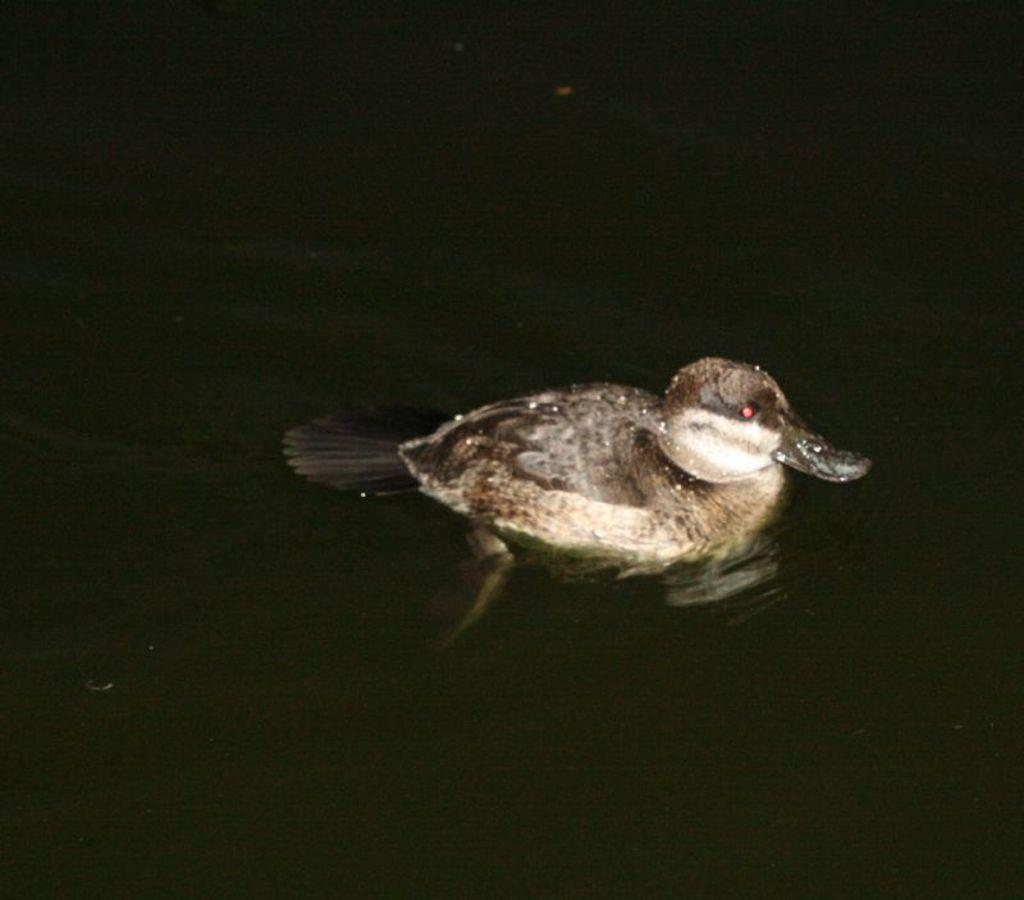What animal is present in the image? There is a duck in the image. Where is the duck located? The duck is in the water. What flavor of duck is depicted in the image? The image does not provide information about the flavor of the duck, as it is a photograph of a real duck and not a representation of a specific flavor. 